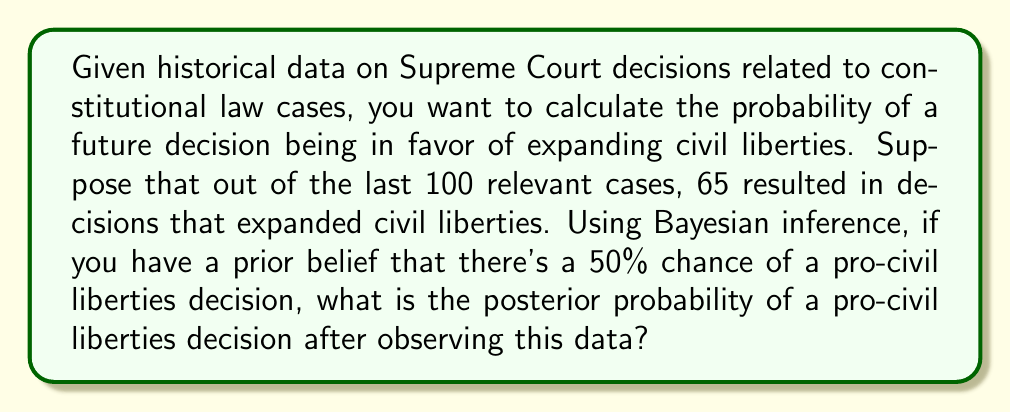Could you help me with this problem? To solve this problem, we'll use Bayes' theorem and the beta distribution as a conjugate prior for the binomial likelihood. This approach is particularly relevant for analyzing Supreme Court decisions, as it allows us to update our beliefs based on observed data.

Step 1: Define the prior distribution
Let's use a beta distribution with parameters $\alpha_0 = \beta_0 = 1$, which represents a uniform prior (equivalent to our 50% prior belief).

Step 2: Update the beta distribution parameters
After observing 65 successes (pro-civil liberties decisions) out of 100 trials, we update the parameters:
$\alpha_1 = \alpha_0 + 65 = 1 + 65 = 66$
$\beta_1 = \beta_0 + (100 - 65) = 1 + 35 = 36$

Step 3: Calculate the posterior probability
The posterior mean of the beta distribution represents our updated belief about the probability of a pro-civil liberties decision:

$$P(\text{pro-civil liberties}) = \frac{\alpha_1}{\alpha_1 + \beta_1} = \frac{66}{66 + 36} = \frac{66}{102}$$

Step 4: Simplify the fraction
$$\frac{66}{102} = \frac{33}{51} \approx 0.6471$$

Therefore, the posterior probability of a pro-civil liberties decision, given the historical data and our prior belief, is approximately 0.6471 or 64.71%.
Answer: $\frac{33}{51} \approx 0.6471$ 